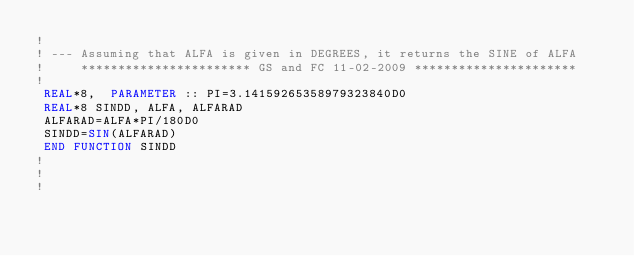<code> <loc_0><loc_0><loc_500><loc_500><_FORTRAN_>!
! --- Assuming that ALFA is given in DEGREES, it returns the SINE of ALFA
!     *********************** GS and FC 11-02-2009 **********************
!	
 REAL*8,  PARAMETER :: PI=3.14159265358979323840D0 
 REAL*8 SINDD, ALFA, ALFARAD		  
 ALFARAD=ALFA*PI/180D0	 
 SINDD=SIN(ALFARAD)	 
 END FUNCTION SINDD 
!
!
!
</code> 